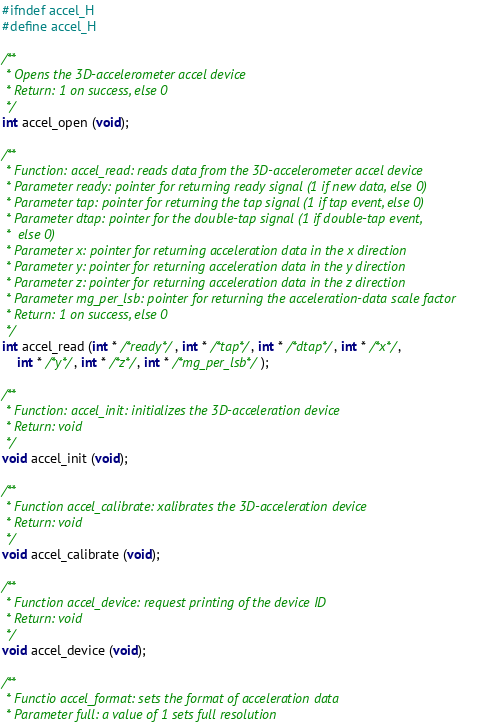Convert code to text. <code><loc_0><loc_0><loc_500><loc_500><_C_>#ifndef accel_H
#define accel_H

/**
 * Opens the 3D-accelerometer accel device
 * Return: 1 on success, else 0
 */
int accel_open (void);

/**
 * Function: accel_read: reads data from the 3D-accelerometer accel device
 * Parameter ready: pointer for returning ready signal (1 if new data, else 0)
 * Parameter tap: pointer for returning the tap signal (1 if tap event, else 0)
 * Parameter dtap: pointer for the double-tap signal (1 if double-tap event, 
 * 	else 0)
 * Parameter x: pointer for returning acceleration data in the x direction
 * Parameter y: pointer for returning acceleration data in the y direction
 * Parameter z: pointer for returning acceleration data in the z direction
 * Parameter mg_per_lsb: pointer for returning the acceleration-data scale factor 
 * Return: 1 on success, else 0
 */
int accel_read (int * /*ready*/, int * /*tap*/, int * /*dtap*/, int * /*x*/, 
	int * /*y*/, int * /*z*/, int * /*mg_per_lsb*/);

/**
 * Function: accel_init: initializes the 3D-acceleration device
 * Return: void
 */
void accel_init (void);

/**
 * Function accel_calibrate: xalibrates the 3D-acceleration device
 * Return: void
 */
void accel_calibrate (void);

/**
 * Function accel_device: request printing of the device ID
 * Return: void
 */
void accel_device (void);

/**
 * Functio accel_format: sets the format of acceleration data
 * Parameter full: a value of 1 sets full resolution</code> 